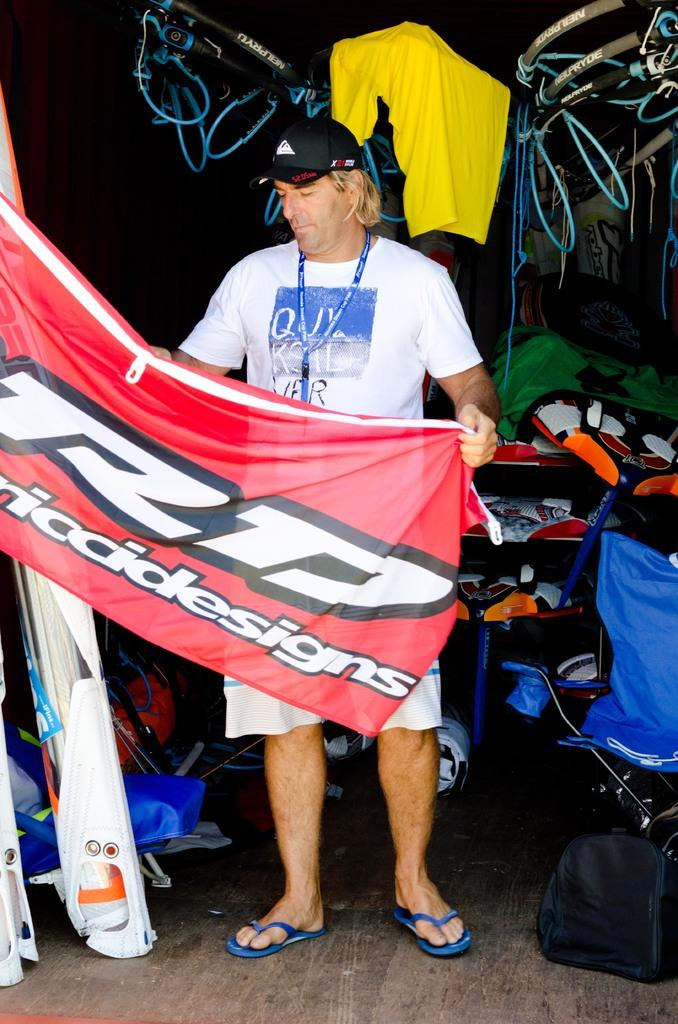<image>
Render a clear and concise summary of the photo. man holding out a banner for a design company 